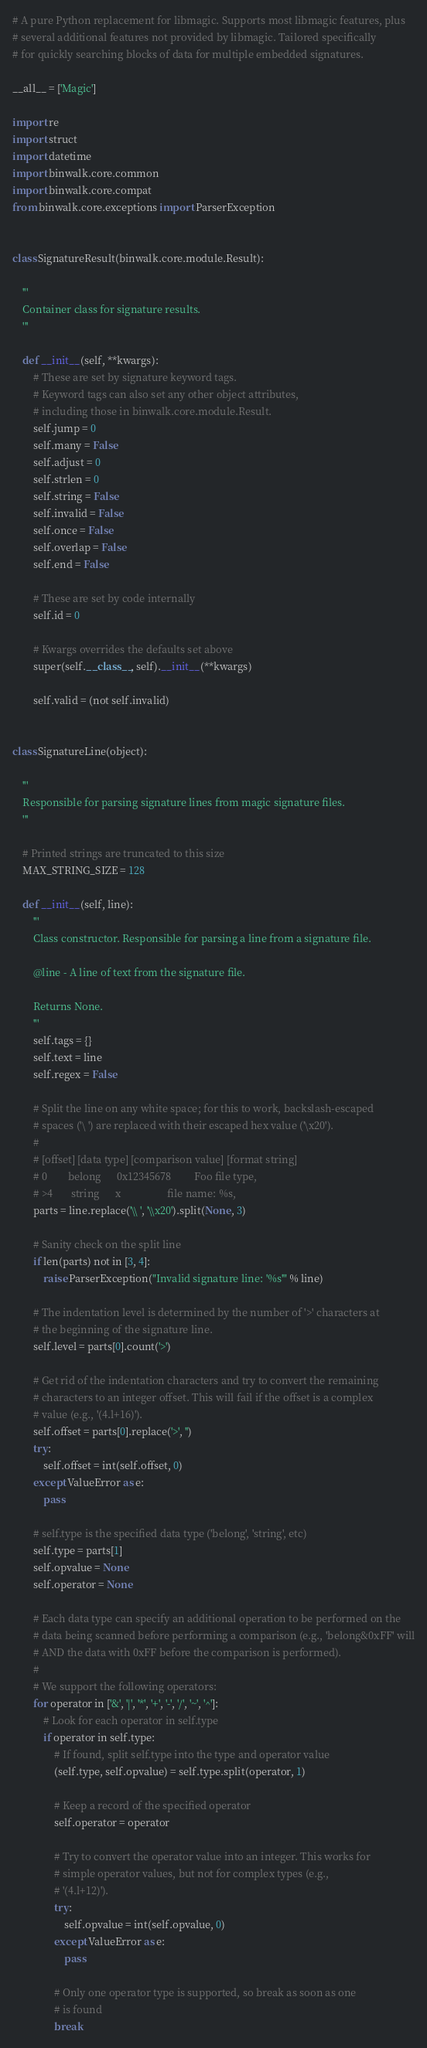<code> <loc_0><loc_0><loc_500><loc_500><_Python_># A pure Python replacement for libmagic. Supports most libmagic features, plus
# several additional features not provided by libmagic. Tailored specifically
# for quickly searching blocks of data for multiple embedded signatures.

__all__ = ['Magic']

import re
import struct
import datetime
import binwalk.core.common
import binwalk.core.compat
from binwalk.core.exceptions import ParserException


class SignatureResult(binwalk.core.module.Result):

    '''
    Container class for signature results.
    '''

    def __init__(self, **kwargs):
        # These are set by signature keyword tags.
        # Keyword tags can also set any other object attributes,
        # including those in binwalk.core.module.Result.
        self.jump = 0
        self.many = False
        self.adjust = 0
        self.strlen = 0
        self.string = False
        self.invalid = False
        self.once = False
        self.overlap = False
        self.end = False

        # These are set by code internally
        self.id = 0

        # Kwargs overrides the defaults set above
        super(self.__class__, self).__init__(**kwargs)

        self.valid = (not self.invalid)


class SignatureLine(object):

    '''
    Responsible for parsing signature lines from magic signature files.
    '''

    # Printed strings are truncated to this size
    MAX_STRING_SIZE = 128

    def __init__(self, line):
        '''
        Class constructor. Responsible for parsing a line from a signature file.

        @line - A line of text from the signature file.

        Returns None.
        '''
        self.tags = {}
        self.text = line
        self.regex = False

        # Split the line on any white space; for this to work, backslash-escaped
        # spaces ('\ ') are replaced with their escaped hex value ('\x20').
        #
        # [offset] [data type] [comparison value] [format string]
        # 0        belong      0x12345678         Foo file type,
        # >4       string      x                  file name: %s,
        parts = line.replace('\\ ', '\\x20').split(None, 3)

        # Sanity check on the split line
        if len(parts) not in [3, 4]:
            raise ParserException("Invalid signature line: '%s'" % line)

        # The indentation level is determined by the number of '>' characters at
        # the beginning of the signature line.
        self.level = parts[0].count('>')

        # Get rid of the indentation characters and try to convert the remaining
        # characters to an integer offset. This will fail if the offset is a complex
        # value (e.g., '(4.l+16)').
        self.offset = parts[0].replace('>', '')
        try:
            self.offset = int(self.offset, 0)
        except ValueError as e:
            pass

        # self.type is the specified data type ('belong', 'string', etc)
        self.type = parts[1]
        self.opvalue = None
        self.operator = None

        # Each data type can specify an additional operation to be performed on the
        # data being scanned before performing a comparison (e.g., 'belong&0xFF' will
        # AND the data with 0xFF before the comparison is performed).
        #
        # We support the following operators:
        for operator in ['&', '|', '*', '+', '-', '/', '~', '^']:
            # Look for each operator in self.type
            if operator in self.type:
                # If found, split self.type into the type and operator value
                (self.type, self.opvalue) = self.type.split(operator, 1)

                # Keep a record of the specified operator
                self.operator = operator

                # Try to convert the operator value into an integer. This works for
                # simple operator values, but not for complex types (e.g.,
                # '(4.l+12)').
                try:
                    self.opvalue = int(self.opvalue, 0)
                except ValueError as e:
                    pass

                # Only one operator type is supported, so break as soon as one
                # is found
                break
</code> 